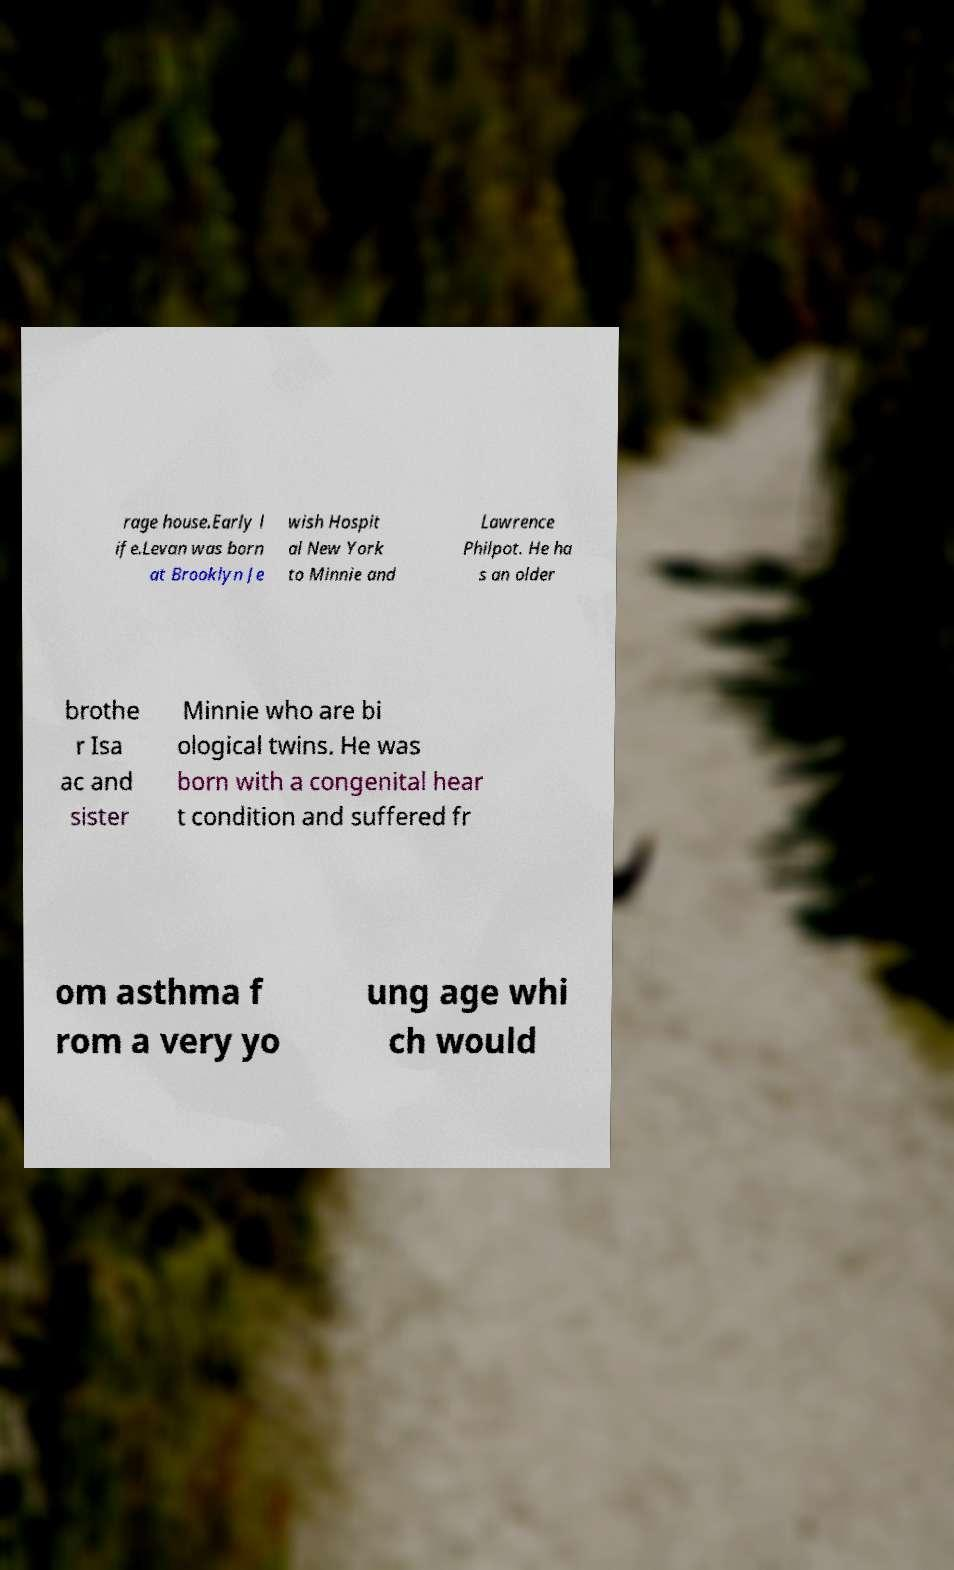Please identify and transcribe the text found in this image. rage house.Early l ife.Levan was born at Brooklyn Je wish Hospit al New York to Minnie and Lawrence Philpot. He ha s an older brothe r Isa ac and sister Minnie who are bi ological twins. He was born with a congenital hear t condition and suffered fr om asthma f rom a very yo ung age whi ch would 